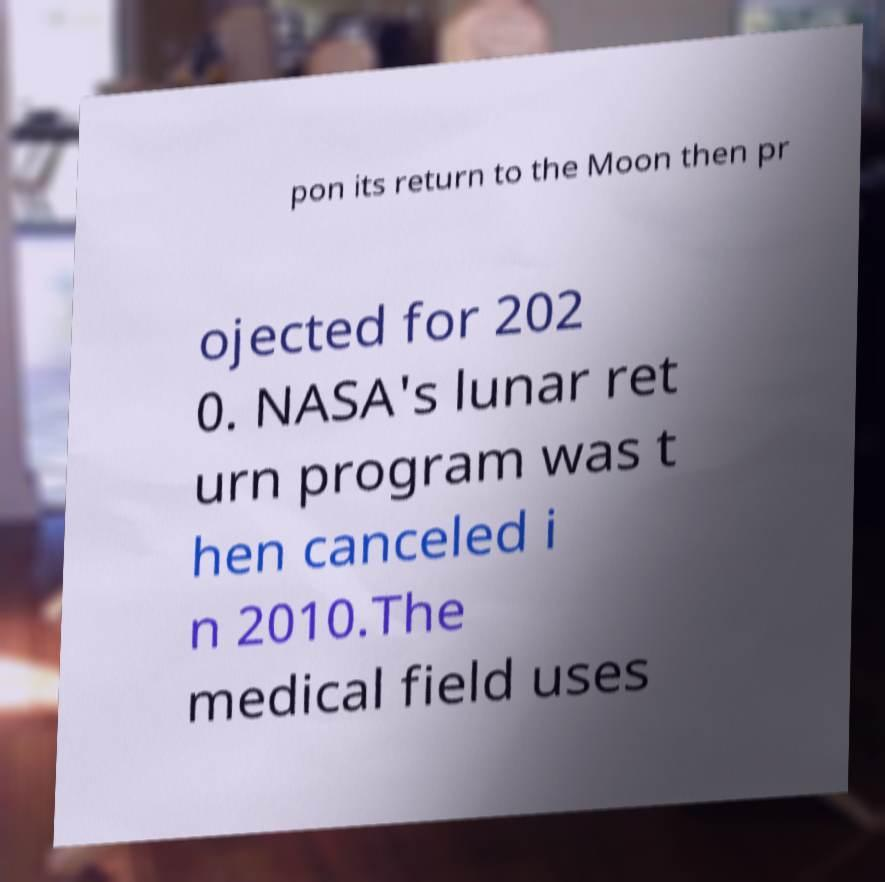Please identify and transcribe the text found in this image. pon its return to the Moon then pr ojected for 202 0. NASA's lunar ret urn program was t hen canceled i n 2010.The medical field uses 